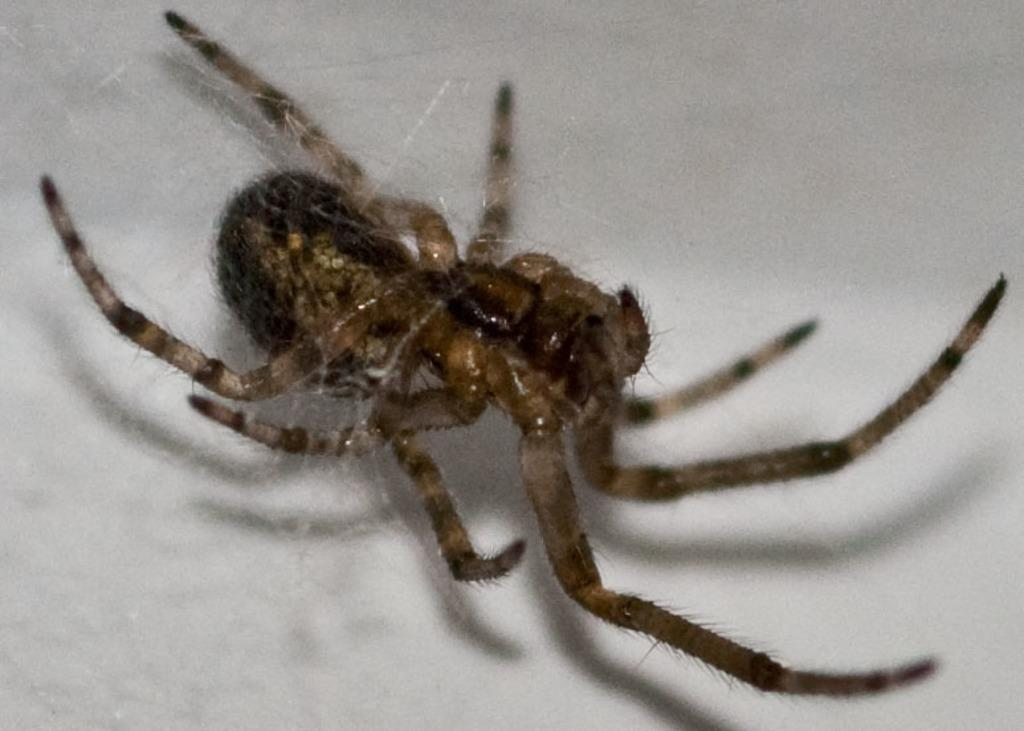What is the main subject of the image? The main subject of the image is a spider. Can you describe the appearance of the spider? The spider is brown and black in color. How is the spider positioned in the image? The spider is attached to its web. What is the color of the background in the image? The background of the image is white. What type of amusement can be seen in the image? There is no amusement present in the image; it features a spider attached to its web. How many fangs does the spider have in the image? The number of fangs cannot be determined from the image, as the spider's fangs are not visible. 